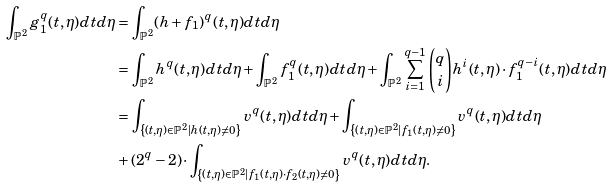<formula> <loc_0><loc_0><loc_500><loc_500>\int _ { \mathbb { P } ^ { 2 } } g _ { 1 } ^ { q } ( t , \eta ) d t d \eta & = \int _ { \mathbb { P } ^ { 2 } } ( h + f _ { 1 } ) ^ { q } ( t , \eta ) d t d \eta \\ & = \int _ { \mathbb { P } ^ { 2 } } h ^ { q } ( t , \eta ) d t d \eta + \int _ { \mathbb { P } ^ { 2 } } f _ { 1 } ^ { q } ( t , \eta ) d t d \eta + \int _ { \mathbb { P } ^ { 2 } } \sum _ { i = 1 } ^ { q - 1 } \binom { q } { i } h ^ { i } ( t , \eta ) \cdot f _ { 1 } ^ { q - i } ( t , \eta ) d t d \eta \\ & = \int _ { \left \{ ( t , \eta ) \in \mathbb { P } ^ { 2 } | h ( t , \eta ) \neq 0 \right \} } v ^ { q } ( t , \eta ) d t d \eta + \int _ { \left \{ ( t , \eta ) \in \mathbb { P } ^ { 2 } | f _ { 1 } ( t , \eta ) \neq 0 \right \} } v ^ { q } ( t , \eta ) d t d \eta \\ & + ( 2 ^ { q } - 2 ) \cdot \int _ { \left \{ ( t , \eta ) \in \mathbb { P } ^ { 2 } | f _ { 1 } ( t , \eta ) \cdot f _ { 2 } ( t , \eta ) \neq 0 \right \} } v ^ { q } ( t , \eta ) d t d \eta .</formula> 